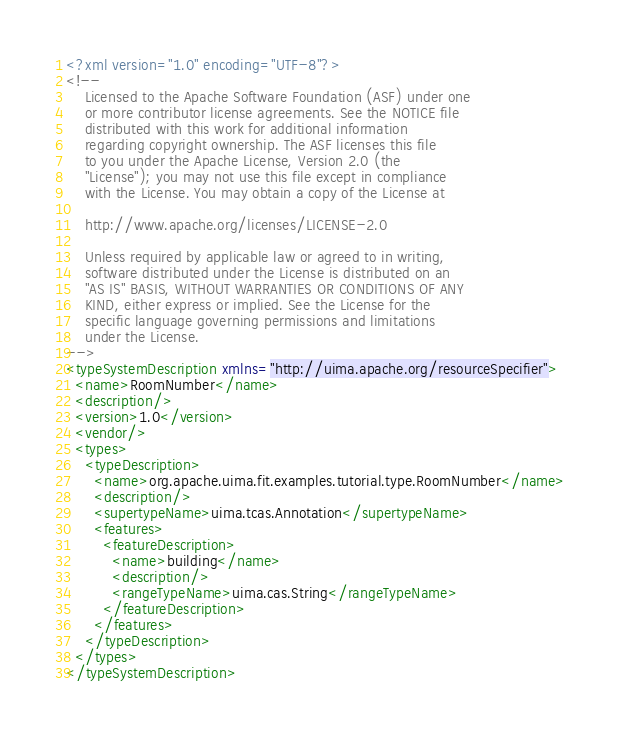<code> <loc_0><loc_0><loc_500><loc_500><_XML_><?xml version="1.0" encoding="UTF-8"?>
<!--
	Licensed to the Apache Software Foundation (ASF) under one
	or more contributor license agreements. See the NOTICE file
	distributed with this work for additional information
	regarding copyright ownership. The ASF licenses this file
	to you under the Apache License, Version 2.0 (the
	"License"); you may not use this file except in compliance
	with the License. You may obtain a copy of the License at

	http://www.apache.org/licenses/LICENSE-2.0

	Unless required by applicable law or agreed to in writing,
	software distributed under the License is distributed on an
	"AS IS" BASIS, WITHOUT WARRANTIES OR CONDITIONS OF ANY
	KIND, either express or implied. See the License for the
	specific language governing permissions and limitations
	under the License.
-->
<typeSystemDescription xmlns="http://uima.apache.org/resourceSpecifier">
  <name>RoomNumber</name>
  <description/>
  <version>1.0</version>
  <vendor/>
  <types>
    <typeDescription>
      <name>org.apache.uima.fit.examples.tutorial.type.RoomNumber</name>
      <description/>
      <supertypeName>uima.tcas.Annotation</supertypeName>
      <features>
        <featureDescription>
          <name>building</name>
          <description/>
          <rangeTypeName>uima.cas.String</rangeTypeName>
        </featureDescription>
      </features>
    </typeDescription>
  </types>
</typeSystemDescription>
</code> 